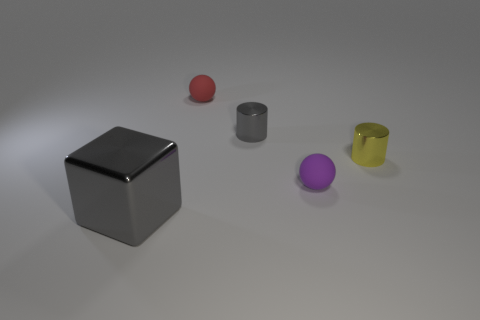The thing that is left of the small gray cylinder and behind the large metallic object is what color?
Provide a succinct answer. Red. What is the material of the cylinder behind the yellow metallic cylinder that is on the right side of the gray object on the right side of the tiny red object?
Your response must be concise. Metal. What is the material of the tiny red thing?
Your answer should be compact. Rubber. What size is the other rubber object that is the same shape as the purple rubber object?
Offer a terse response. Small. How many other objects are there of the same material as the purple sphere?
Keep it short and to the point. 1. Are there the same number of gray shiny cylinders to the left of the small gray metal cylinder and tiny matte cylinders?
Your answer should be very brief. Yes. There is a shiny thing that is in front of the yellow cylinder; does it have the same size as the gray shiny cylinder?
Offer a terse response. No. There is a red matte object; how many cylinders are to the left of it?
Your answer should be compact. 0. There is a tiny object that is on the left side of the tiny purple object and in front of the red object; what material is it?
Make the answer very short. Metal. How many large things are either cyan rubber balls or yellow shiny objects?
Provide a succinct answer. 0. 